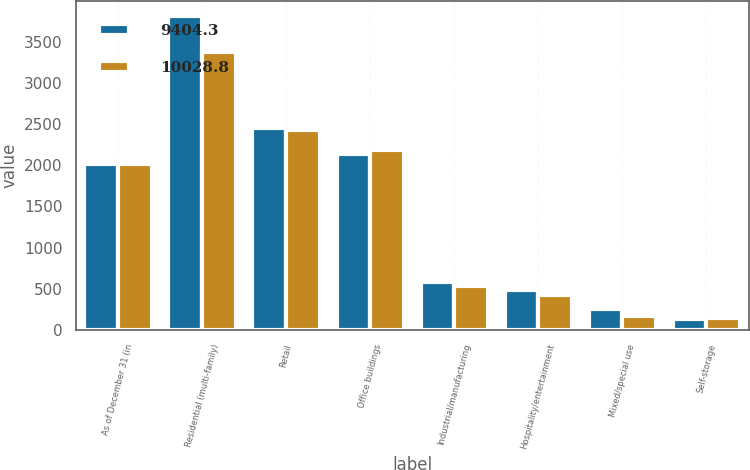Convert chart. <chart><loc_0><loc_0><loc_500><loc_500><stacked_bar_chart><ecel><fcel>As of December 31 (in<fcel>Residential (multi-family)<fcel>Retail<fcel>Office buildings<fcel>Industrial/manufacturing<fcel>Hospitality/entertainment<fcel>Mixed/special use<fcel>Self-storage<nl><fcel>9404.3<fcel>2015<fcel>3807.2<fcel>2450.5<fcel>2137.3<fcel>578.4<fcel>490.2<fcel>259.2<fcel>136.7<nl><fcel>10028.8<fcel>2014<fcel>3378.4<fcel>2422<fcel>2185.3<fcel>538.6<fcel>424.2<fcel>165.2<fcel>147.3<nl></chart> 